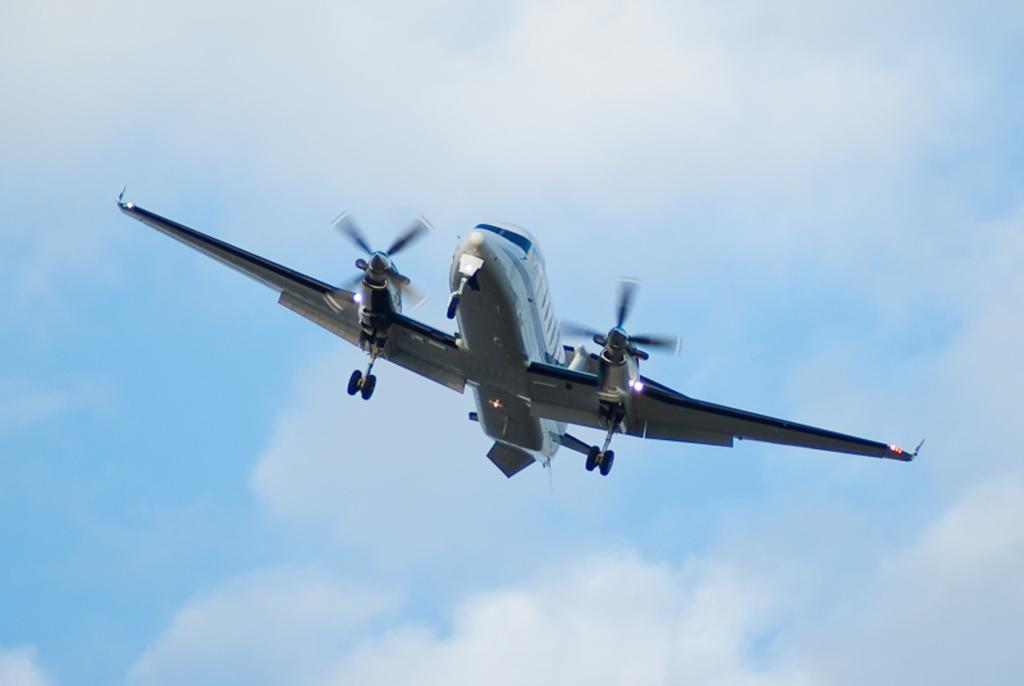In one or two sentences, can you explain what this image depicts? There is an aircraft in the center of the image and the sky in the background. 